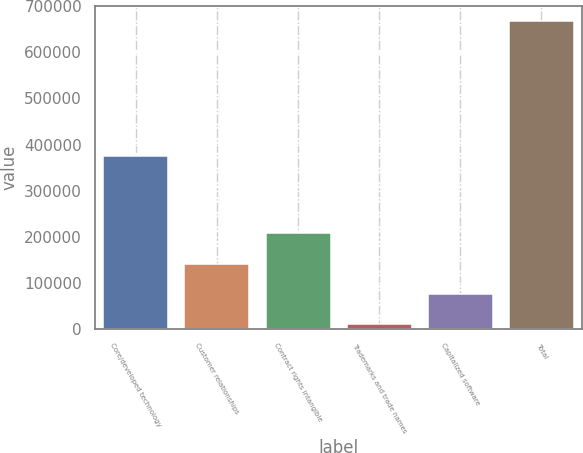<chart> <loc_0><loc_0><loc_500><loc_500><bar_chart><fcel>Core/developed technology<fcel>Customer relationships<fcel>Contract rights intangible<fcel>Trademarks and trade names<fcel>Capitalized software<fcel>Total<nl><fcel>375395<fcel>141919<fcel>207546<fcel>10665<fcel>76292<fcel>666935<nl></chart> 